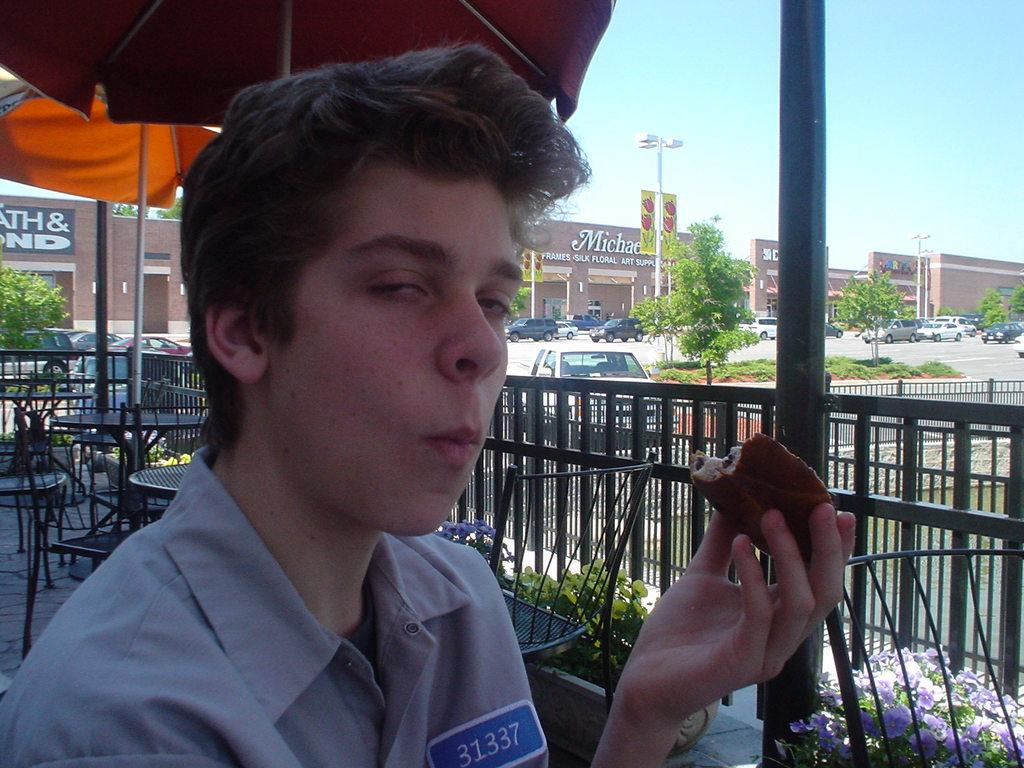<image>
Write a terse but informative summary of the picture. A boy is outside at a restaurant at a strip mall and his shirt has a name tag on it that says "31337". 